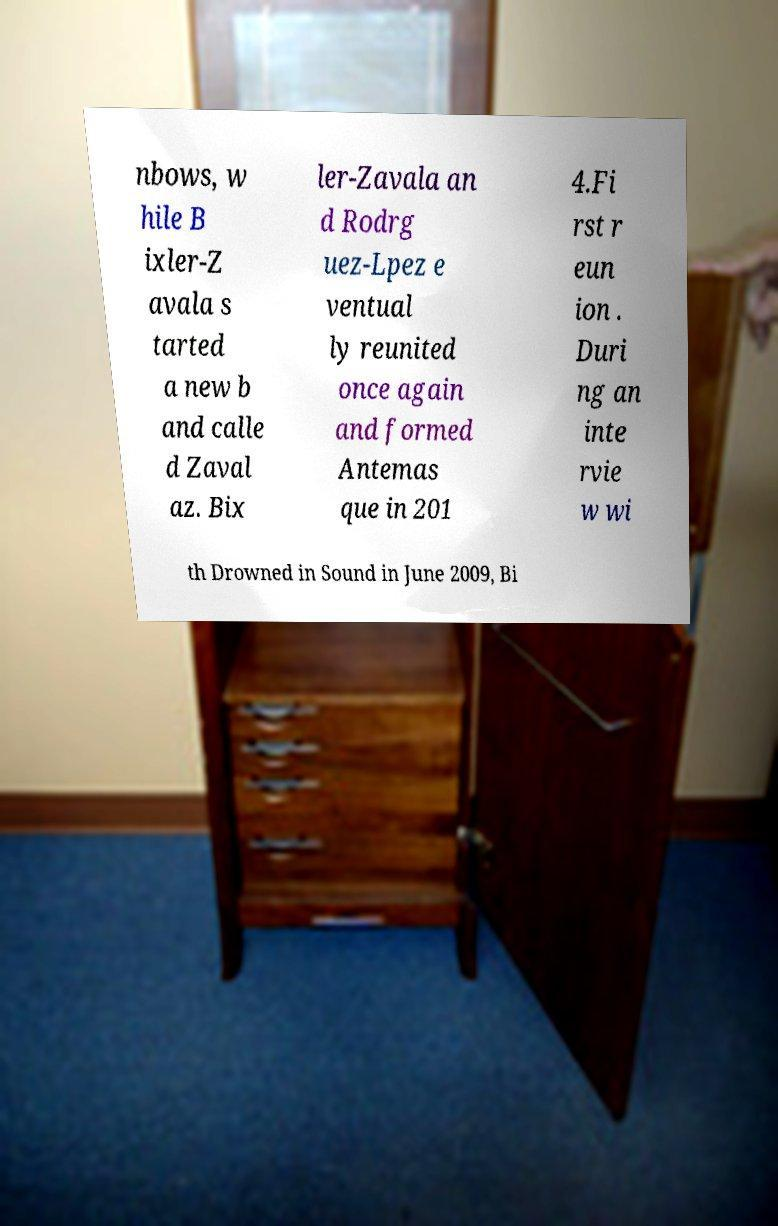Can you read and provide the text displayed in the image?This photo seems to have some interesting text. Can you extract and type it out for me? nbows, w hile B ixler-Z avala s tarted a new b and calle d Zaval az. Bix ler-Zavala an d Rodrg uez-Lpez e ventual ly reunited once again and formed Antemas que in 201 4.Fi rst r eun ion . Duri ng an inte rvie w wi th Drowned in Sound in June 2009, Bi 